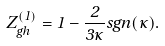<formula> <loc_0><loc_0><loc_500><loc_500>Z _ { g h } ^ { ( 1 ) } = 1 - \frac { 2 } { 3 \kappa } s g n ( \kappa ) .</formula> 